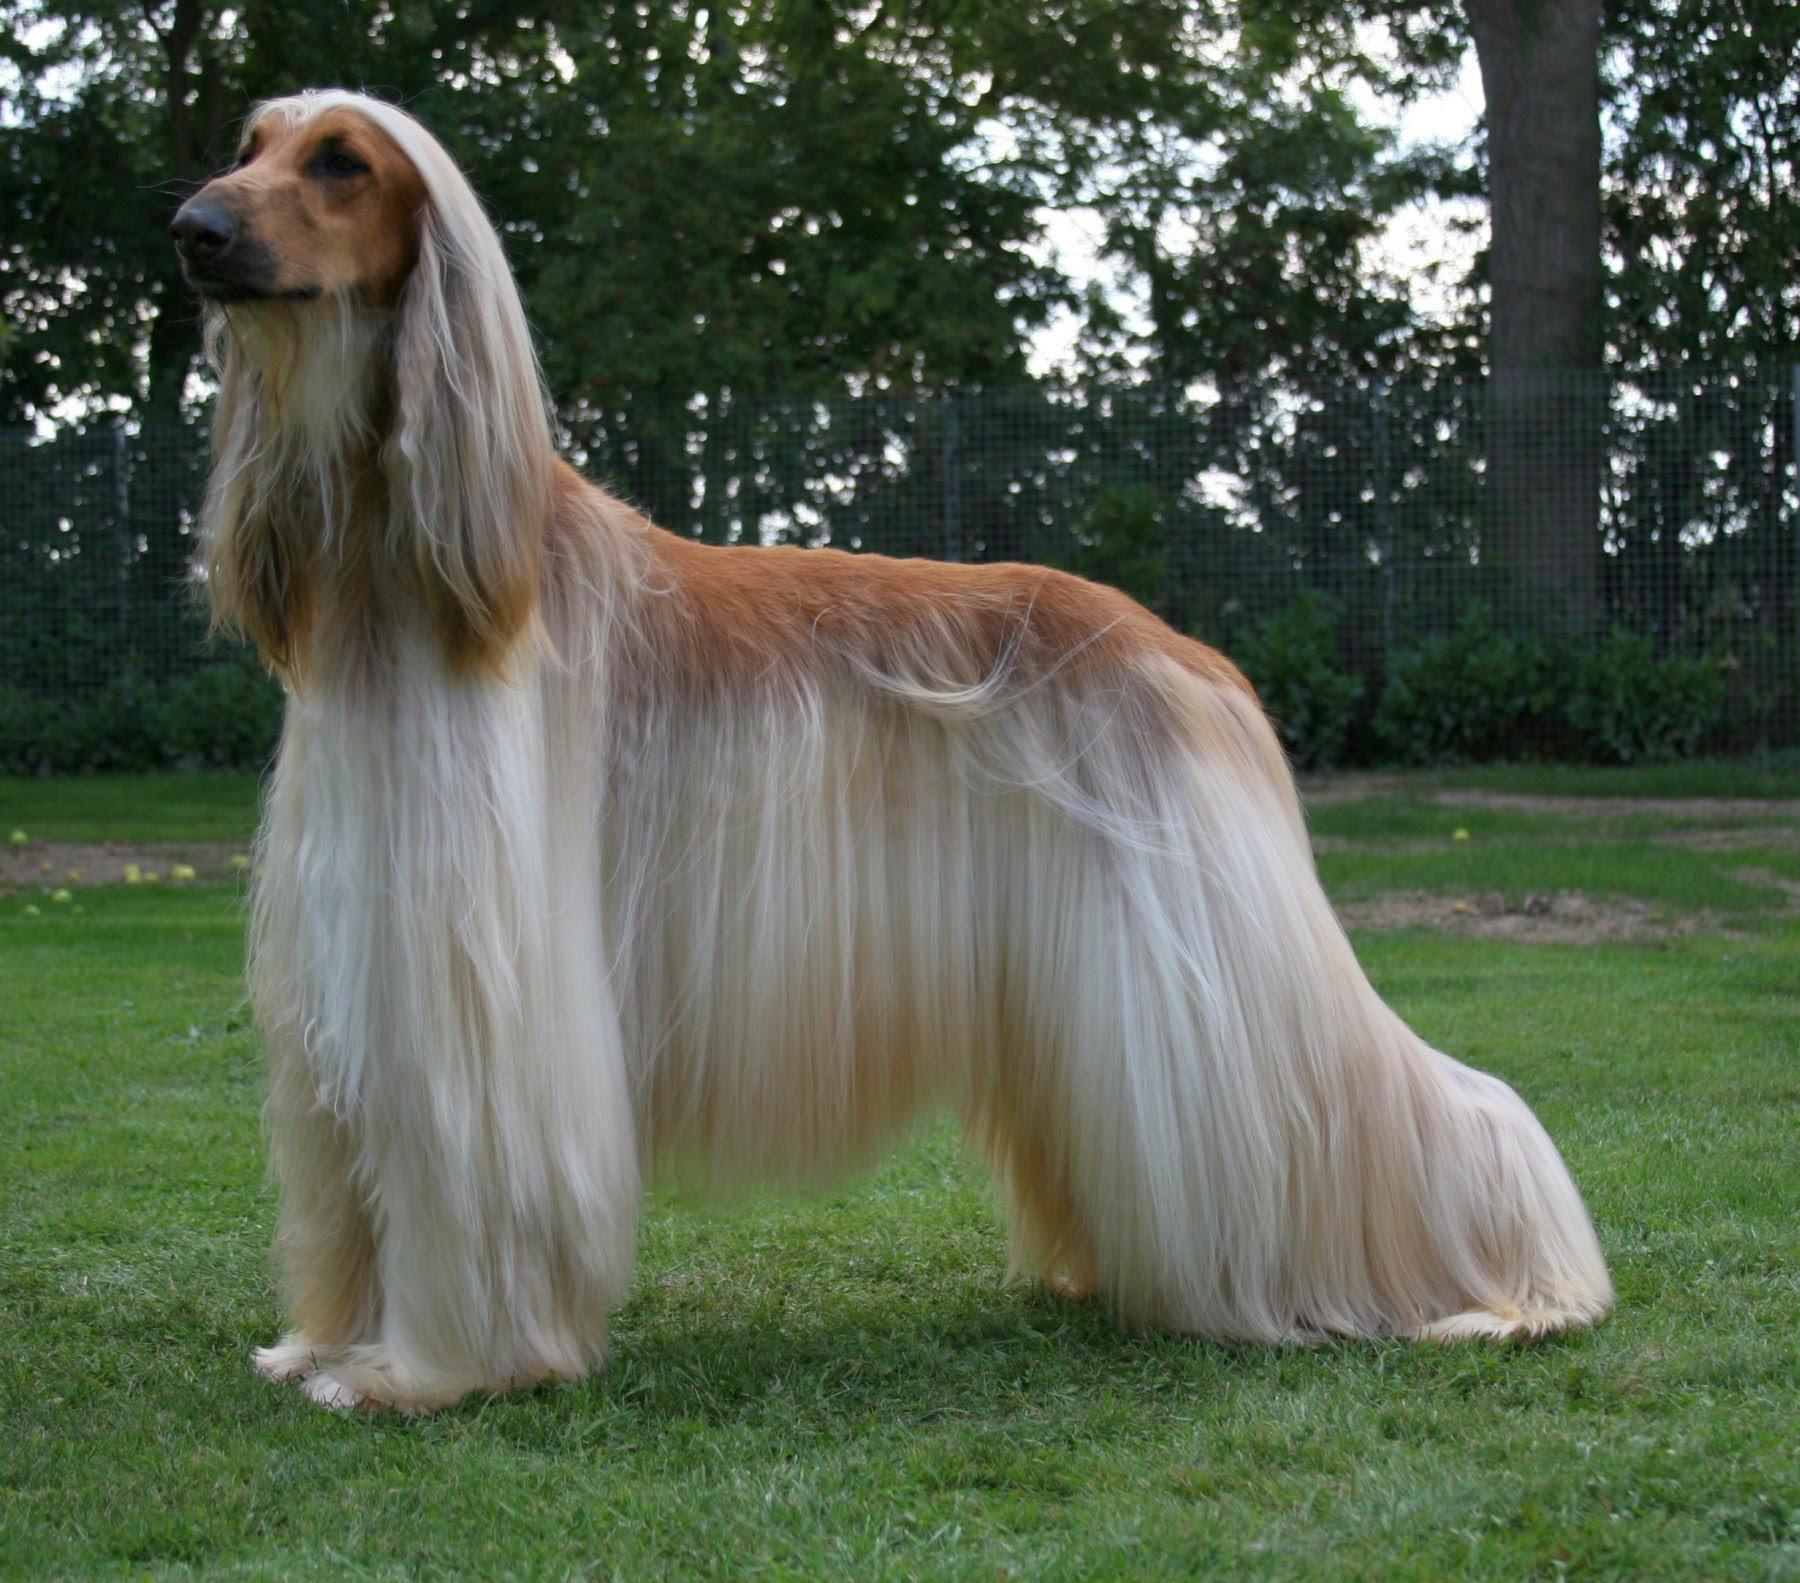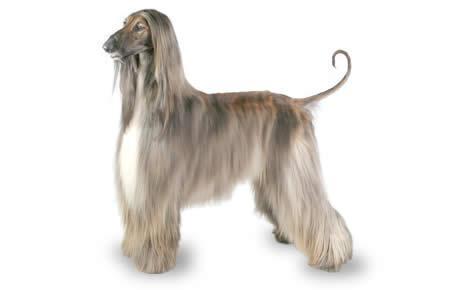The first image is the image on the left, the second image is the image on the right. For the images shown, is this caption "There are no less than three dogs" true? Answer yes or no. No. The first image is the image on the left, the second image is the image on the right. Examine the images to the left and right. Is the description "Both dogs are facing the same direction." accurate? Answer yes or no. Yes. 